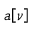Convert formula to latex. <formula><loc_0><loc_0><loc_500><loc_500>a \, \left [ \nu \right ]</formula> 